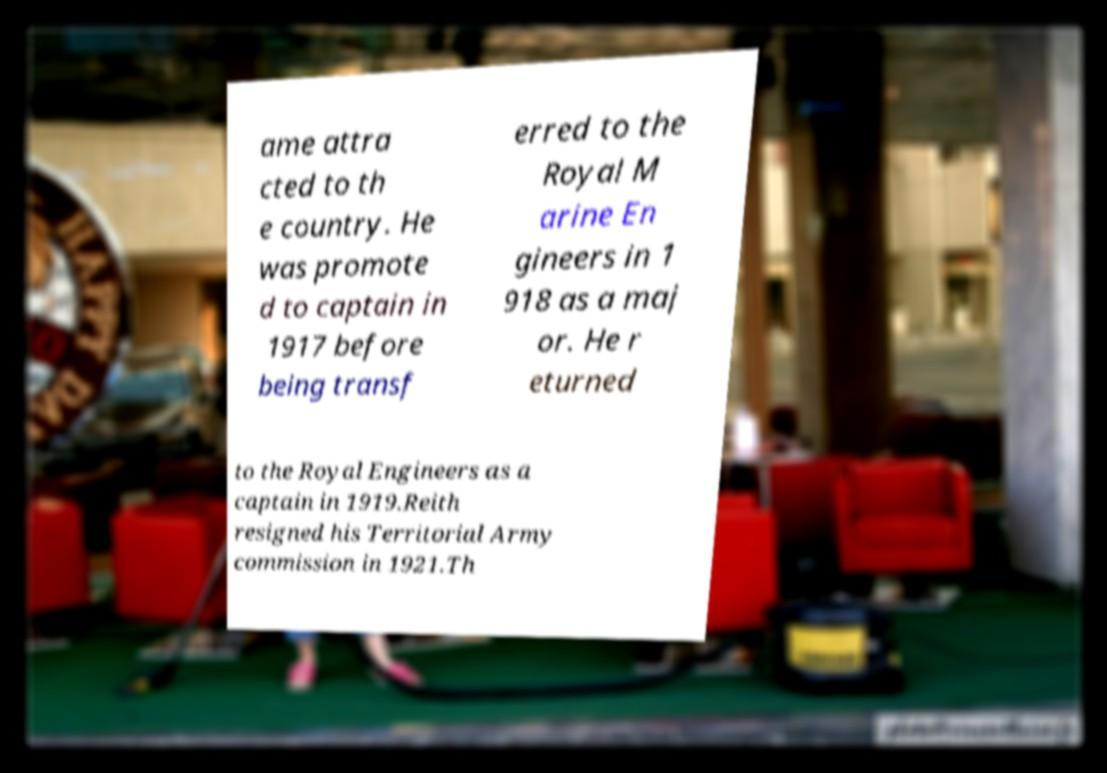There's text embedded in this image that I need extracted. Can you transcribe it verbatim? ame attra cted to th e country. He was promote d to captain in 1917 before being transf erred to the Royal M arine En gineers in 1 918 as a maj or. He r eturned to the Royal Engineers as a captain in 1919.Reith resigned his Territorial Army commission in 1921.Th 